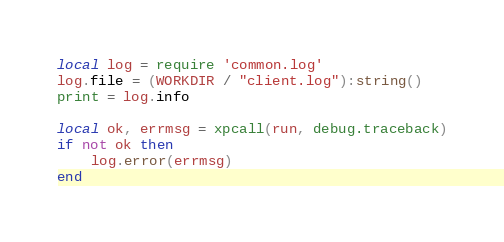Convert code to text. <code><loc_0><loc_0><loc_500><loc_500><_Lua_>local log = require 'common.log'
log.file = (WORKDIR / "client.log"):string()
print = log.info

local ok, errmsg = xpcall(run, debug.traceback)
if not ok then
    log.error(errmsg)
end
</code> 